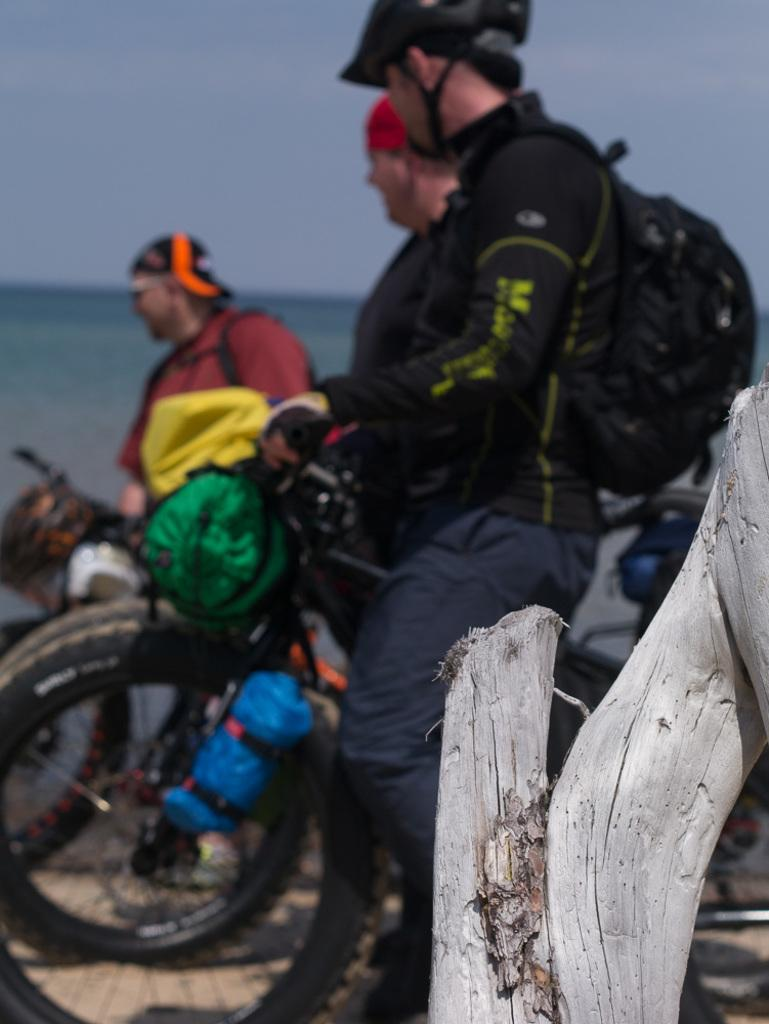How many people are in the image? There are three persons in the image. What is one person doing in the image? One person is sitting on a bicycle. What accessories is the person on the bicycle wearing? The person on the bicycle is wearing a backpack and a helmet. What can be seen in the background of the image? There is sky and water visible in the background of the image. What is the weight of the person on the bicycle? The weight of the person on the bicycle cannot be determined from the image. Is there a dock visible in the image? There is no dock present in the image. 